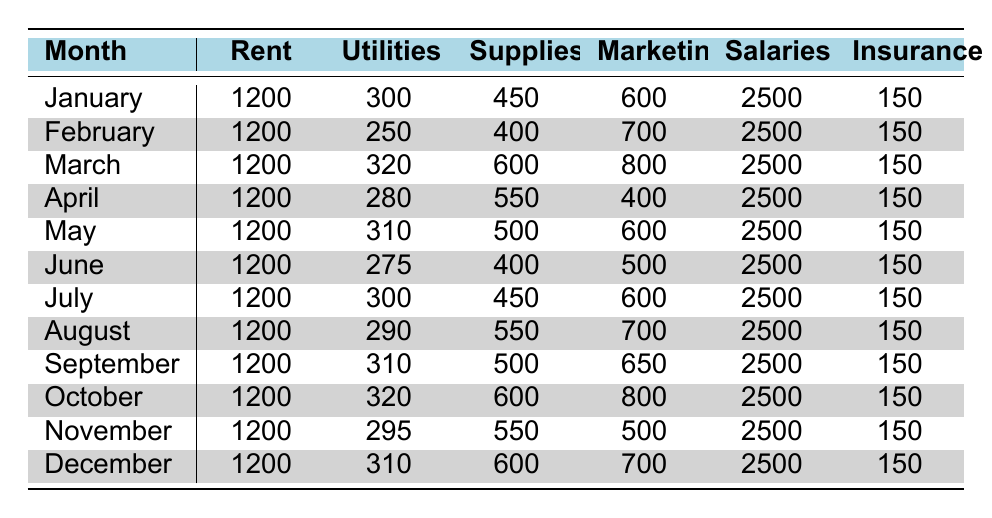What is the total amount spent on Marketing in March? In March, the amount spent on Marketing is $800, as indicated in the table.
Answer: 800 What was the expenditure for Supplies in July? The table shows that in July, the expenditure for Supplies is $450.
Answer: 450 What was the average expense for Utilities over the year? To calculate the average, sum the monthly Utilities expenses: 300 + 250 + 320 + 280 + 310 + 275 + 300 + 290 + 310 + 320 + 295 + 310 = 3,360. Then divide by 12 months: 3360 / 12 = 280.
Answer: 280 Was the total amount spent on Rent in December higher than in November? The Rent amount for both months is $1200, so they are equal. Thus, the statement is false.
Answer: No What was the highest monthly expense for Supplies, and in which month did it occur? The highest expense for Supplies is $600, which occurred in March, October, and December.
Answer: $600 in March, October, and December How much more was spent on Salaries compared to Marketing in April? In April, $2500 was spent on Salaries, and $400 was spent on Marketing. The difference is $2500 - $400 = $2100.
Answer: 2100 What percentage of total expenses in January was spent on Insurance? In January, total expenses were $1200 (Rent) + $300 (Utilities) + $450 (Supplies) + $600 (Marketing) + $2500 (Salaries) + $150 (Insurance) = $4200. The percentage spent on Insurance is (150 / 4200) * 100 = 3.57%.
Answer: 3.57% What is the total expense for the entire year? Sum all monthly expenses from the table: (1200 + 300 + 450 + 600 + 2500 + 150) + (1200 + 250 + 400 + 700 + 2500 + 150) + ... + (1200 + 310 + 600 + 700 + 2500 + 150) = $50,800.
Answer: 50800 In which month was the total amount spent on Utilities the lowest? The lowest amount spent on Utilities was $250 in February, as shown in the table.
Answer: February What was the total expense for both Rent and Salaries over 12 months? The expense for Rent each month is $1200, so for 12 months, it is $1200 * 12 = $14,400. For Salaries, it is $2500 * 12 = $30,000. The combined total is $14,400 + $30,000 = $44,400.
Answer: 44400 Which month had the least expenditure on Marketing? The lowest expenditure on Marketing was $400, which occurred in April.
Answer: April 